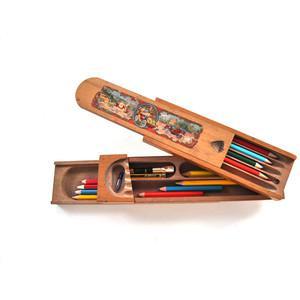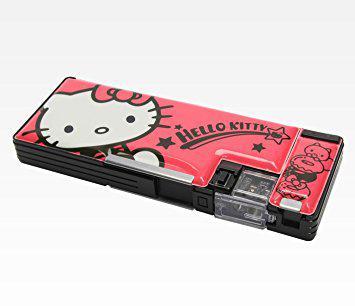The first image is the image on the left, the second image is the image on the right. Examine the images to the left and right. Is the description "An image features a wooden pencil box that slides open, revealing several colored-lead pencils insides." accurate? Answer yes or no. Yes. The first image is the image on the left, the second image is the image on the right. For the images shown, is this caption "The sliding top of a wooden pencil box is opened to display two levels of storage with an end space to store a sharpener, while a leather pencil case is shown in a second image." true? Answer yes or no. No. 